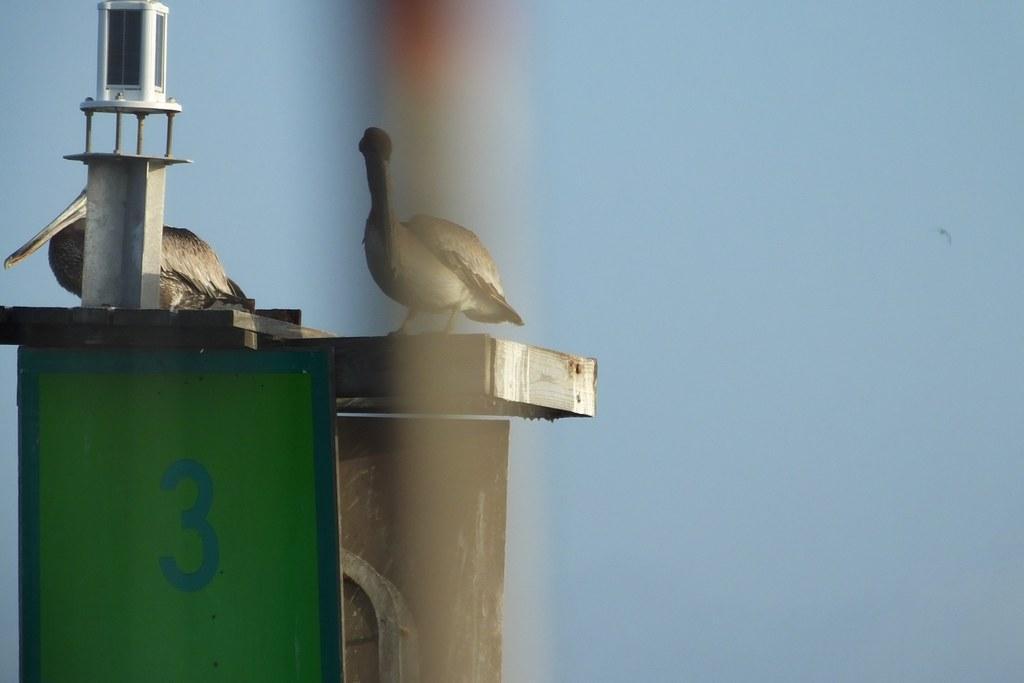How would you summarize this image in a sentence or two? In this image we can able to see two birds and an object on the surface, there is a board with number written on it, and also we can see the sky. 